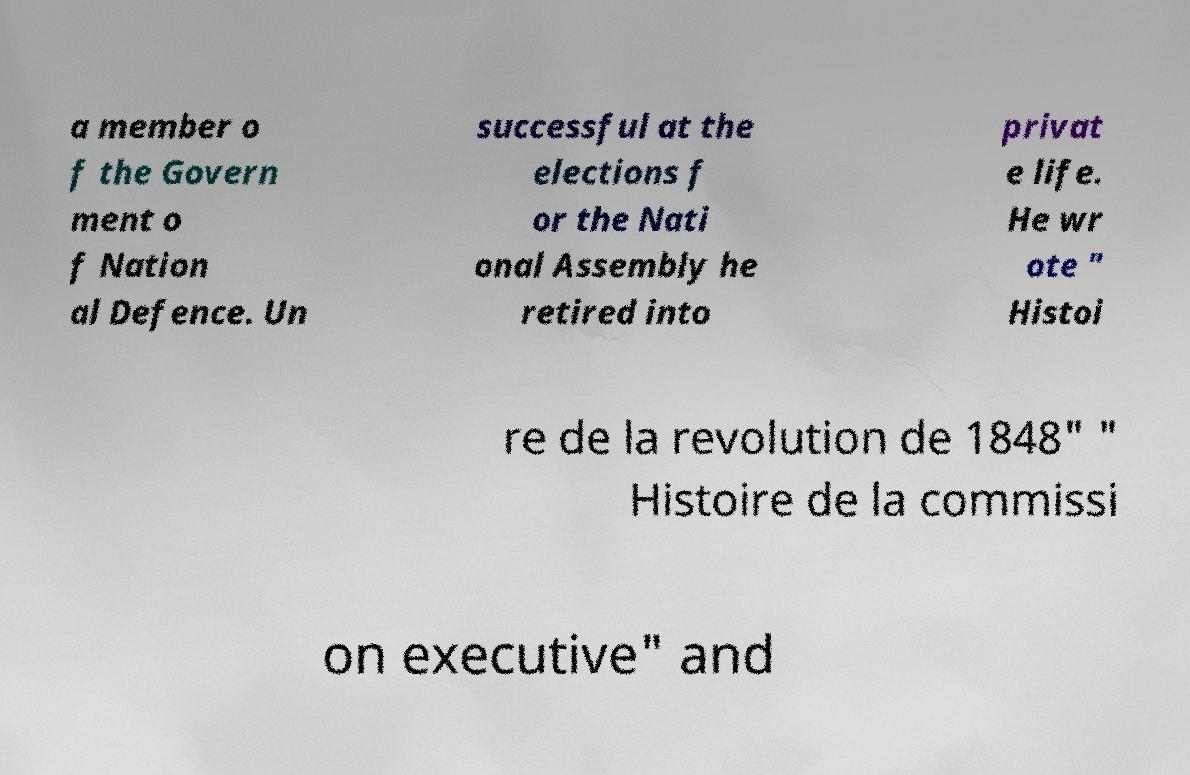Can you read and provide the text displayed in the image?This photo seems to have some interesting text. Can you extract and type it out for me? a member o f the Govern ment o f Nation al Defence. Un successful at the elections f or the Nati onal Assembly he retired into privat e life. He wr ote " Histoi re de la revolution de 1848" " Histoire de la commissi on executive" and 